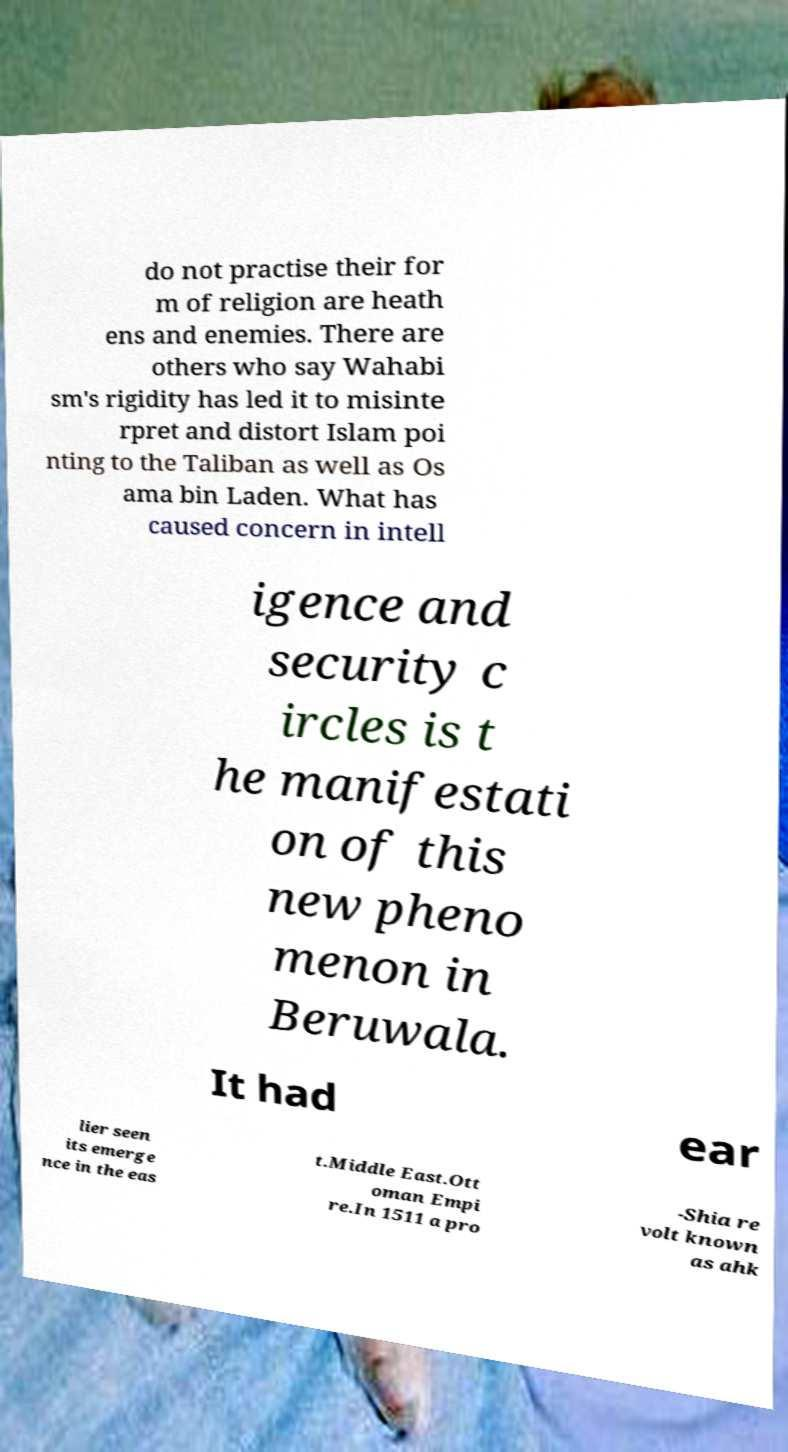Please read and relay the text visible in this image. What does it say? do not practise their for m of religion are heath ens and enemies. There are others who say Wahabi sm's rigidity has led it to misinte rpret and distort Islam poi nting to the Taliban as well as Os ama bin Laden. What has caused concern in intell igence and security c ircles is t he manifestati on of this new pheno menon in Beruwala. It had ear lier seen its emerge nce in the eas t.Middle East.Ott oman Empi re.In 1511 a pro -Shia re volt known as ahk 